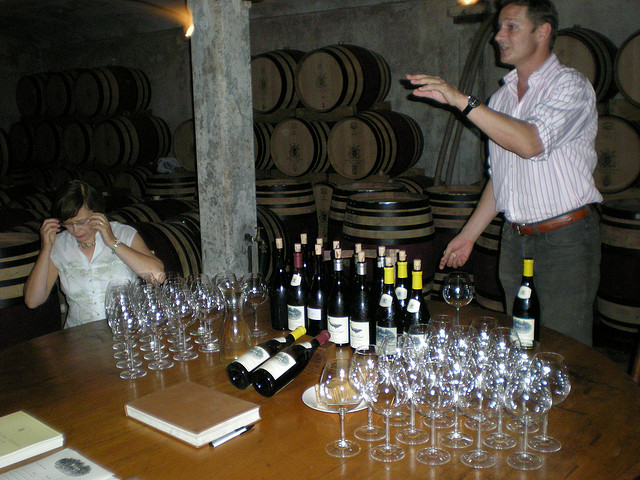What kind of wood is used to make the barrels in the background?
A. oak
B. birch
C. pine
D. mahogany
Answer with the option's letter from the given choices directly. A 